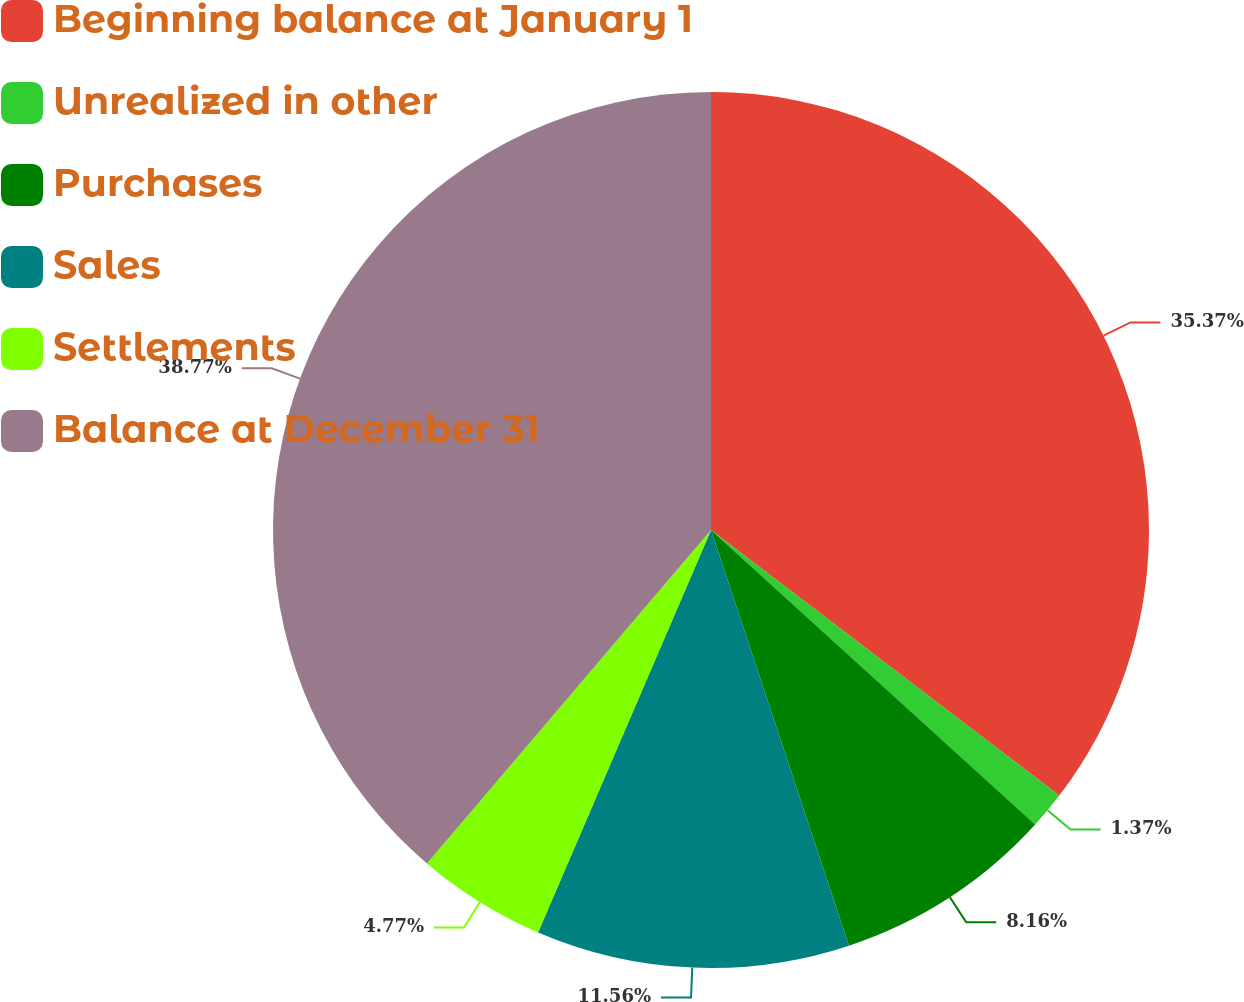Convert chart to OTSL. <chart><loc_0><loc_0><loc_500><loc_500><pie_chart><fcel>Beginning balance at January 1<fcel>Unrealized in other<fcel>Purchases<fcel>Sales<fcel>Settlements<fcel>Balance at December 31<nl><fcel>35.37%<fcel>1.37%<fcel>8.16%<fcel>11.56%<fcel>4.77%<fcel>38.77%<nl></chart> 